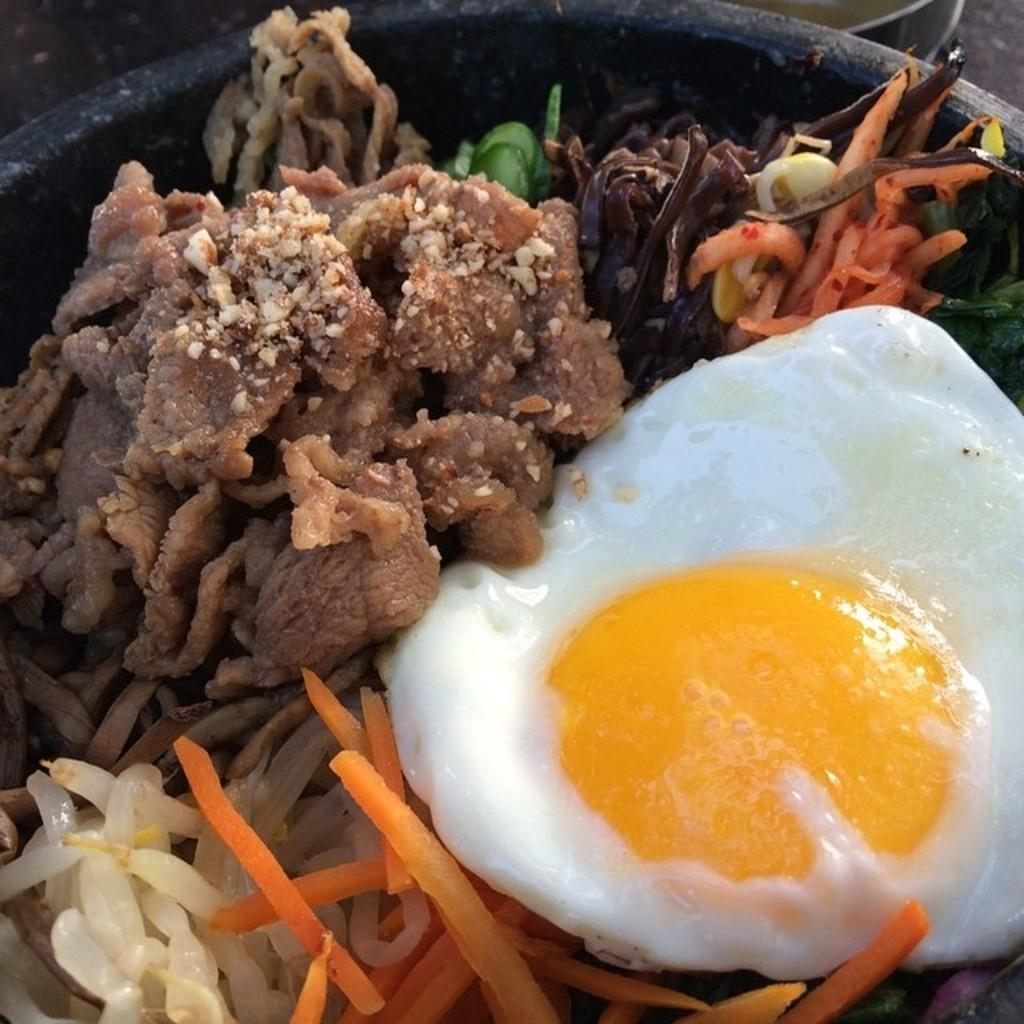What color is the bowl in the image? The bowl in the image is black. What is inside the bowl? There are different food items in the bowl. Is there a ship visible in the image? No, there is no ship present in the image. What type of rice is being served in the bowl? There is no rice mentioned or visible in the image; it contains different food items. 